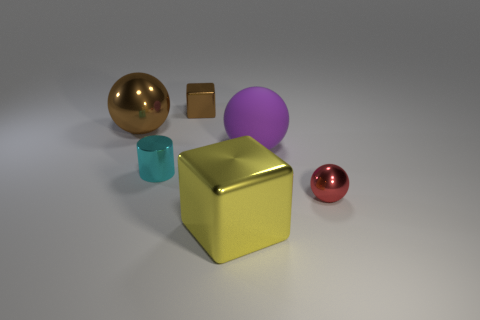There is a cylinder that is made of the same material as the small cube; what size is it?
Give a very brief answer. Small. How big is the red ball?
Your answer should be very brief. Small. What shape is the yellow shiny thing?
Provide a short and direct response. Cube. Do the small shiny thing right of the rubber sphere and the tiny cube have the same color?
Offer a very short reply. No. There is a yellow thing that is the same shape as the tiny brown object; what is its size?
Make the answer very short. Large. Is there anything else that has the same material as the large cube?
Keep it short and to the point. Yes. There is a tiny metal block right of the ball that is left of the brown block; are there any tiny blocks left of it?
Provide a short and direct response. No. What material is the object that is behind the large brown sphere?
Provide a succinct answer. Metal. How many big objects are either cyan objects or yellow cubes?
Ensure brevity in your answer.  1. Is the size of the shiny block in front of the rubber ball the same as the big purple rubber object?
Keep it short and to the point. Yes. 